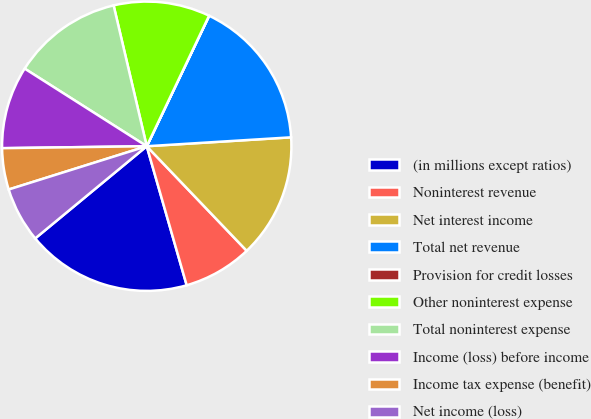<chart> <loc_0><loc_0><loc_500><loc_500><pie_chart><fcel>(in millions except ratios)<fcel>Noninterest revenue<fcel>Net interest income<fcel>Total net revenue<fcel>Provision for credit losses<fcel>Other noninterest expense<fcel>Total noninterest expense<fcel>Income (loss) before income<fcel>Income tax expense (benefit)<fcel>Net income (loss)<nl><fcel>18.46%<fcel>7.69%<fcel>13.84%<fcel>16.92%<fcel>0.01%<fcel>10.77%<fcel>12.31%<fcel>9.23%<fcel>4.62%<fcel>6.16%<nl></chart> 